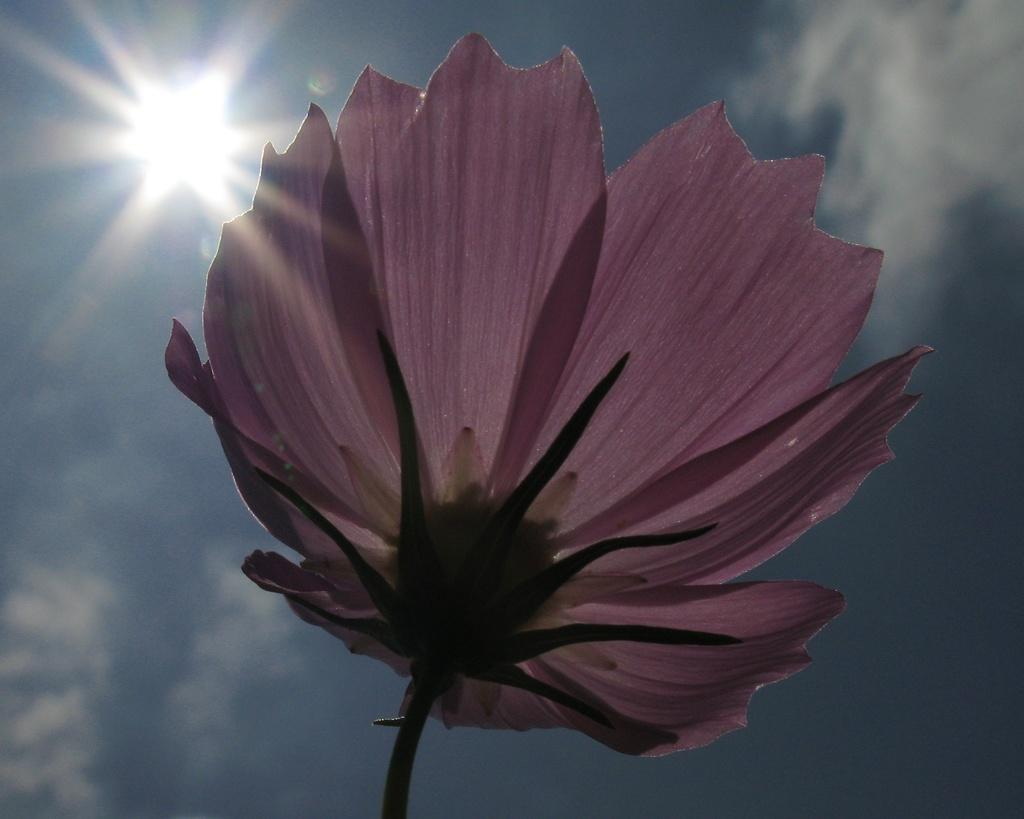What is the main subject of the image? There is a flower in the image. Can you describe the color of the flower? The flower is pink. What can be seen in the background of the image? There is a sun visible in the sky in the background of the image. What type of butter is being used to decorate the flower in the image? There is no butter present in the image, as it features a pink flower with a sun in the background. 